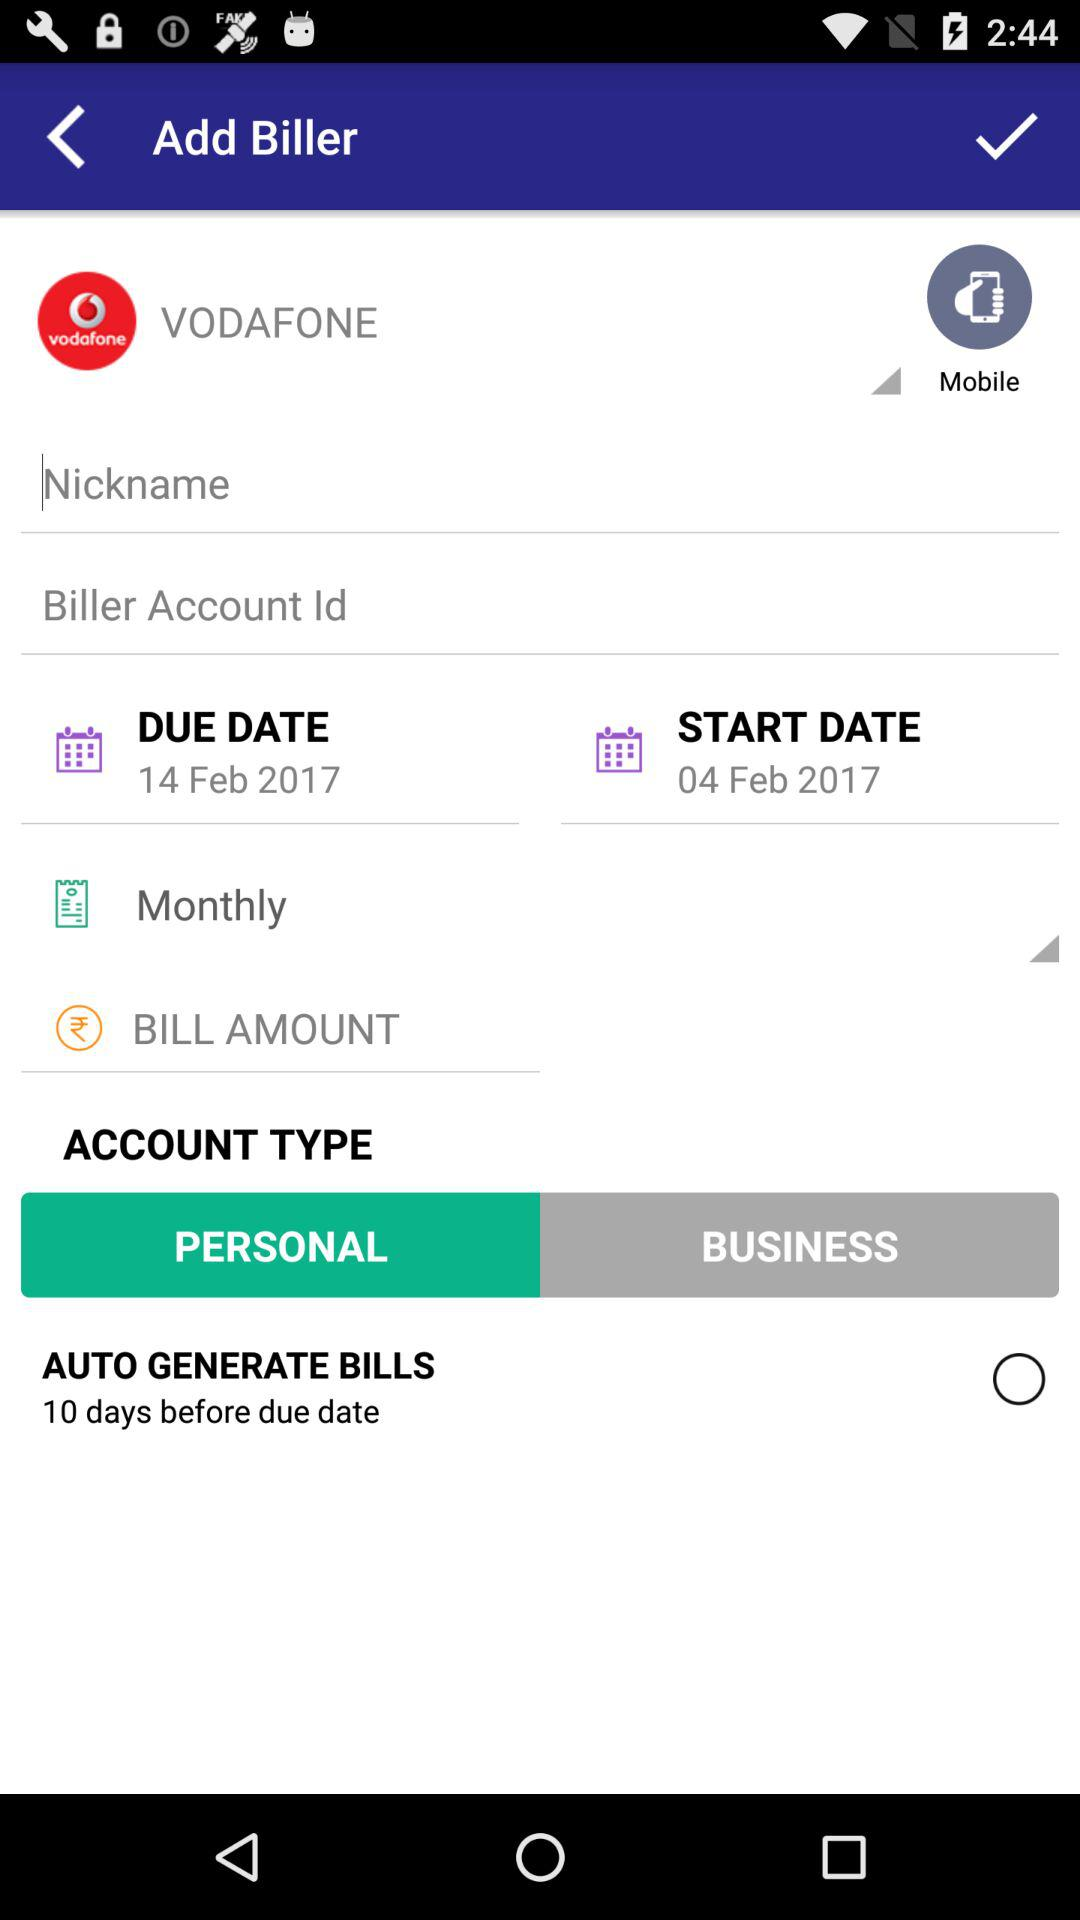Which account type is selected? The selected account type is "PERSONAL". 